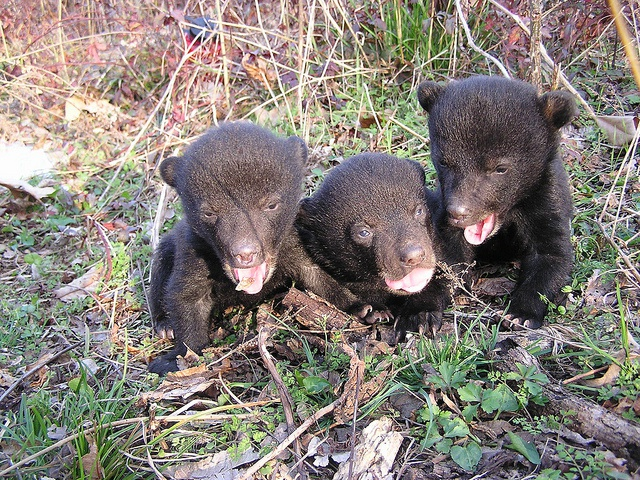Describe the objects in this image and their specific colors. I can see bear in lightpink, black, gray, and darkgray tones, bear in lightpink, gray, black, and darkgray tones, and bear in lightpink, black, gray, and darkgray tones in this image. 